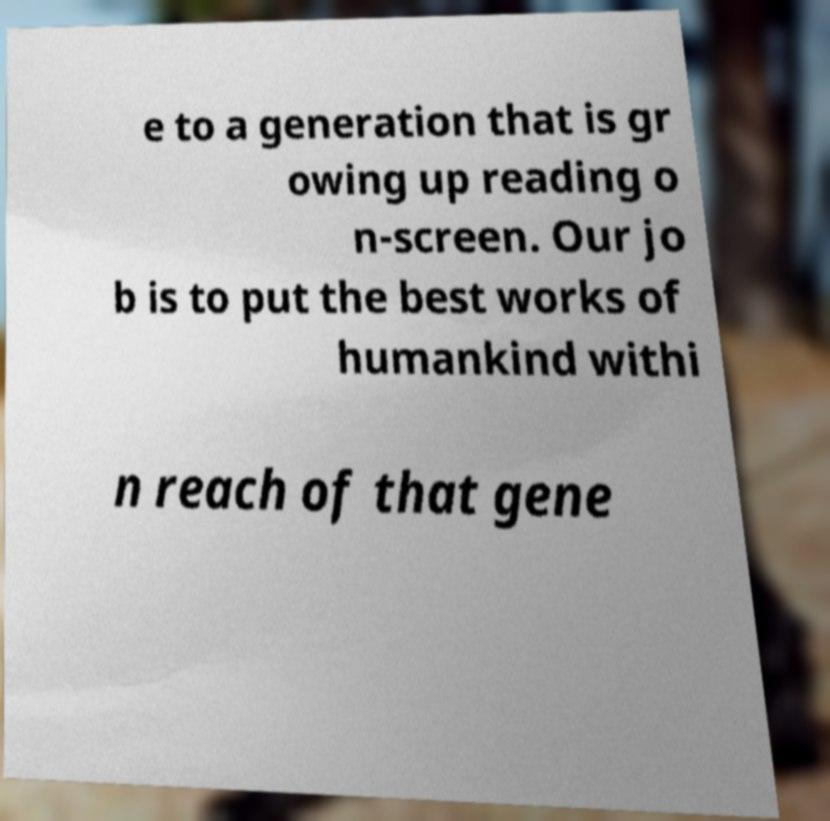Please read and relay the text visible in this image. What does it say? e to a generation that is gr owing up reading o n-screen. Our jo b is to put the best works of humankind withi n reach of that gene 